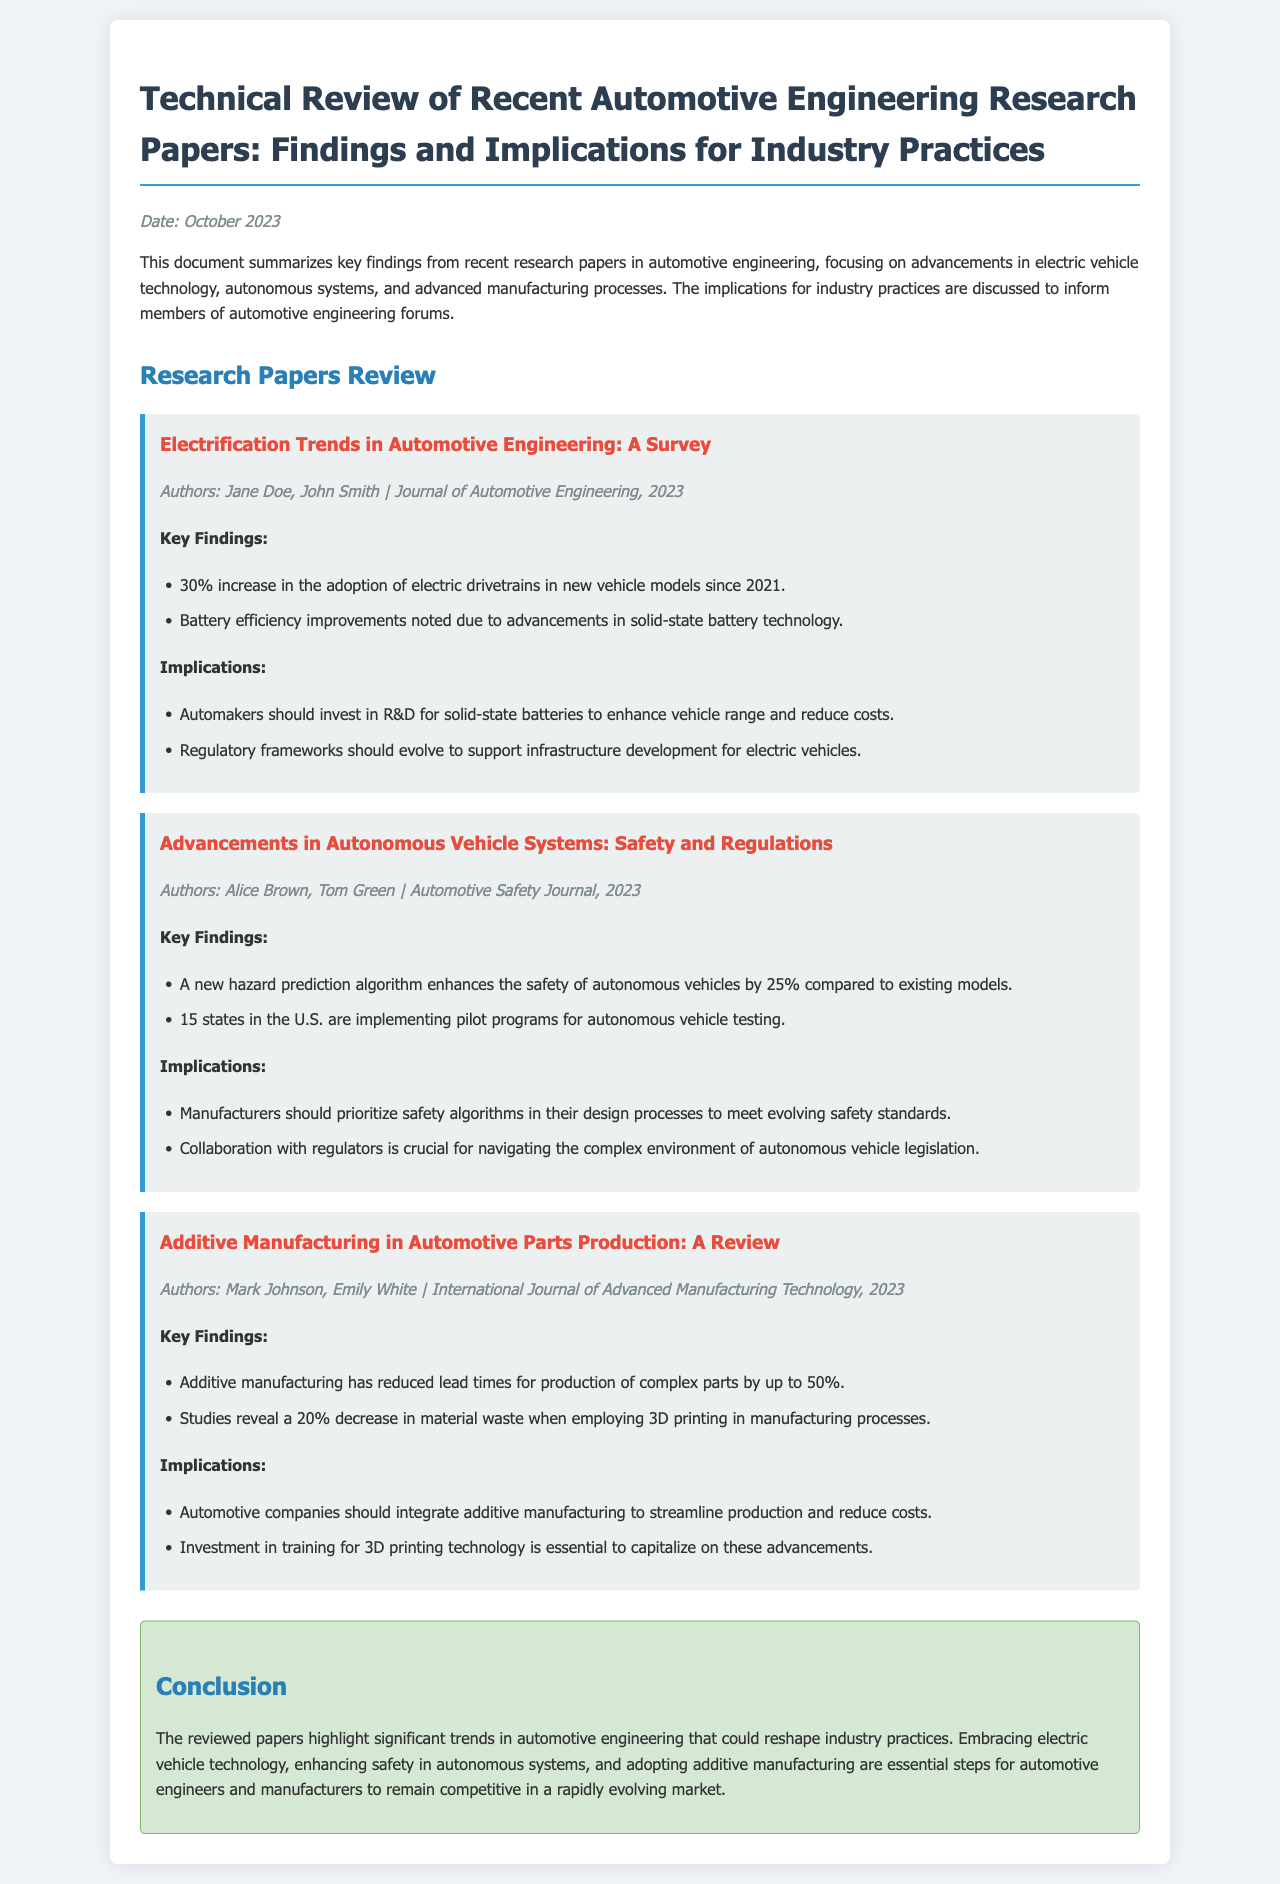What is the date of the document? The date is mentioned at the top of the document, indicating when the review was conducted.
Answer: October 2023 Who are the authors of the paper on electrification trends? The authors' names are listed at the beginning of each paper section.
Answer: Jane Doe, John Smith What was the percentage increase in the adoption of electric drivetrains? This statistic is provided in the key findings of the electrification trends paper.
Answer: 30% What proportion of states in the U.S. are implementing pilot programs for autonomous vehicle testing? The specific number of states is highlighted in the key findings of the autonomous vehicle systems paper.
Answer: 15 states What is the reduction in lead times for complex parts production due to additive manufacturing? This information is stated in the key findings of the additive manufacturing paper.
Answer: 50% What investment is essential for automotive companies to capitalize on 3D printing advancements? The implications section of the additive manufacturing paper discusses necessary investments.
Answer: Training What is a key implication for automakers regarding solid-state batteries? The implications for industry practices include suggestions for investments in battery technologies.
Answer: Invest in R&D Which algorithm enhances the safety of autonomous vehicles? The safety improvement is attributed to a specific algorithm mentioned in the findings.
Answer: Hazard prediction algorithm What is the implication of regulatory frameworks for electric vehicle infrastructure? The implications discussion covers the evolution needed in regulatory frameworks for supporting electric vehicles.
Answer: Evolve to support infrastructure 